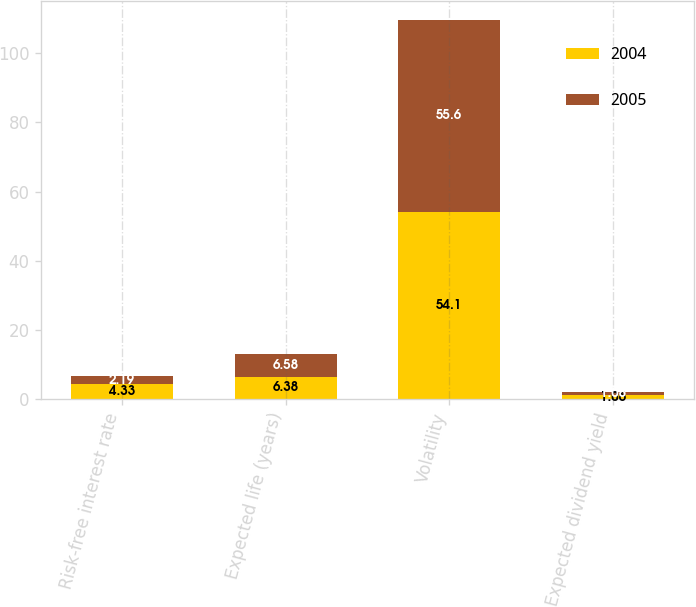<chart> <loc_0><loc_0><loc_500><loc_500><stacked_bar_chart><ecel><fcel>Risk-free interest rate<fcel>Expected life (years)<fcel>Volatility<fcel>Expected dividend yield<nl><fcel>2004<fcel>4.33<fcel>6.38<fcel>54.1<fcel>1.06<nl><fcel>2005<fcel>2.19<fcel>6.58<fcel>55.6<fcel>1.08<nl></chart> 